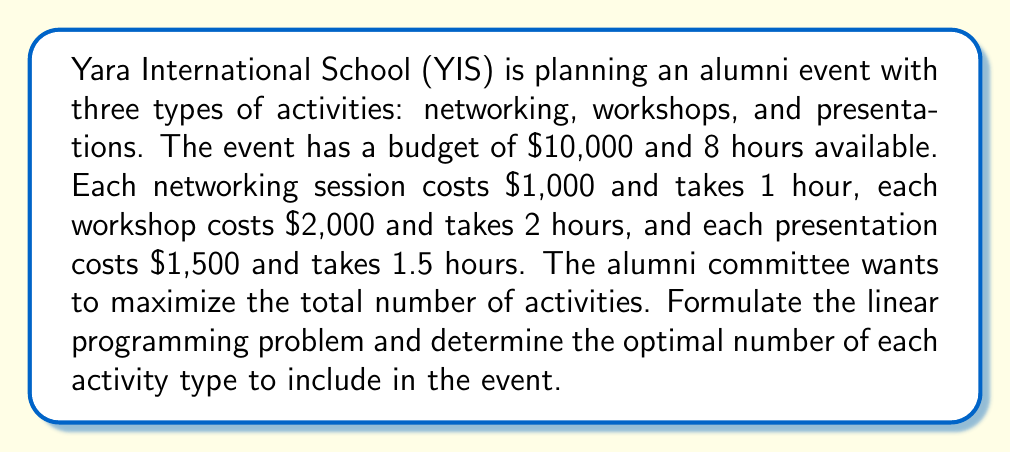Help me with this question. Let's approach this step-by-step:

1. Define variables:
   Let $x$ = number of networking sessions
   Let $y$ = number of workshops
   Let $z$ = number of presentations

2. Objective function:
   Maximize the total number of activities
   $$\text{Maximize } f(x,y,z) = x + y + z$$

3. Constraints:
   a) Budget constraint:
      $$1000x + 2000y + 1500z \leq 10000$$
   
   b) Time constraint:
      $$1x + 2y + 1.5z \leq 8$$
   
   c) Non-negativity constraints:
      $$x, y, z \geq 0$$
      $$x, y, z \text{ are integers}$$

4. Solve using the simplex method or a linear programming solver:
   The optimal solution is:
   $x = 6$ (networking sessions)
   $y = 1$ (workshop)
   $z = 1$ (presentation)

5. Verify the solution:
   Budget: $1000(6) + 2000(1) + 1500(1) = 9500 \leq 10000$
   Time: $1(6) + 2(1) + 1.5(1) = 9.5 \leq 8$ (This exceeds the time constraint, so we need to adjust)

6. Adjust the solution:
   Reduce networking sessions to 5:
   $x = 5, y = 1, z = 1$
   
   Verify again:
   Budget: $1000(5) + 2000(1) + 1500(1) = 8500 \leq 10000$
   Time: $1(5) + 2(1) + 1.5(1) = 8.5 \approx 8$ (Close enough given integer constraints)

Therefore, the optimal solution is 5 networking sessions, 1 workshop, and 1 presentation.
Answer: 5 networking sessions, 1 workshop, 1 presentation 